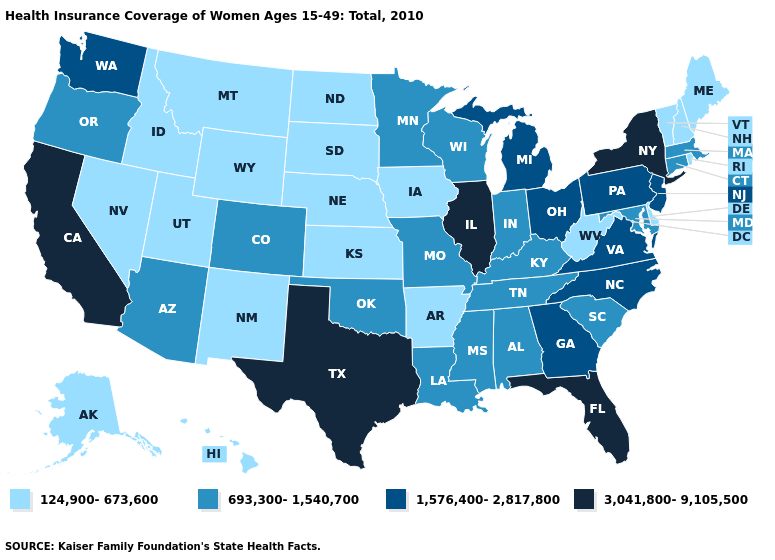What is the highest value in the USA?
Keep it brief. 3,041,800-9,105,500. Name the states that have a value in the range 124,900-673,600?
Quick response, please. Alaska, Arkansas, Delaware, Hawaii, Idaho, Iowa, Kansas, Maine, Montana, Nebraska, Nevada, New Hampshire, New Mexico, North Dakota, Rhode Island, South Dakota, Utah, Vermont, West Virginia, Wyoming. Does Minnesota have the highest value in the MidWest?
Short answer required. No. Name the states that have a value in the range 3,041,800-9,105,500?
Answer briefly. California, Florida, Illinois, New York, Texas. What is the value of California?
Give a very brief answer. 3,041,800-9,105,500. Among the states that border Kansas , which have the highest value?
Give a very brief answer. Colorado, Missouri, Oklahoma. What is the value of New Hampshire?
Concise answer only. 124,900-673,600. How many symbols are there in the legend?
Write a very short answer. 4. Which states have the lowest value in the MidWest?
Write a very short answer. Iowa, Kansas, Nebraska, North Dakota, South Dakota. How many symbols are there in the legend?
Give a very brief answer. 4. Does New York have the highest value in the Northeast?
Be succinct. Yes. Name the states that have a value in the range 124,900-673,600?
Quick response, please. Alaska, Arkansas, Delaware, Hawaii, Idaho, Iowa, Kansas, Maine, Montana, Nebraska, Nevada, New Hampshire, New Mexico, North Dakota, Rhode Island, South Dakota, Utah, Vermont, West Virginia, Wyoming. Name the states that have a value in the range 1,576,400-2,817,800?
Concise answer only. Georgia, Michigan, New Jersey, North Carolina, Ohio, Pennsylvania, Virginia, Washington. What is the value of Connecticut?
Give a very brief answer. 693,300-1,540,700. What is the lowest value in the West?
Concise answer only. 124,900-673,600. 